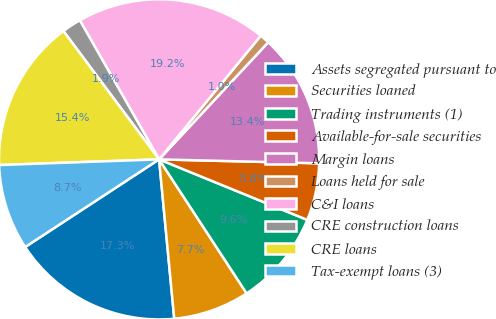Convert chart to OTSL. <chart><loc_0><loc_0><loc_500><loc_500><pie_chart><fcel>Assets segregated pursuant to<fcel>Securities loaned<fcel>Trading instruments (1)<fcel>Available-for-sale securities<fcel>Margin loans<fcel>Loans held for sale<fcel>C&I loans<fcel>CRE construction loans<fcel>CRE loans<fcel>Tax-exempt loans (3)<nl><fcel>17.29%<fcel>7.7%<fcel>9.62%<fcel>5.78%<fcel>13.45%<fcel>0.99%<fcel>19.2%<fcel>1.95%<fcel>15.37%<fcel>8.66%<nl></chart> 